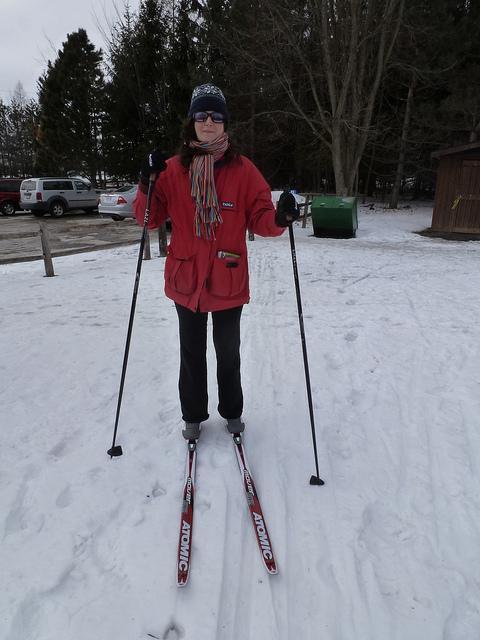How many vehicles are in the background?
Give a very brief answer. 2. How many trucks are in the picture?
Give a very brief answer. 1. How many ski are visible?
Give a very brief answer. 1. 